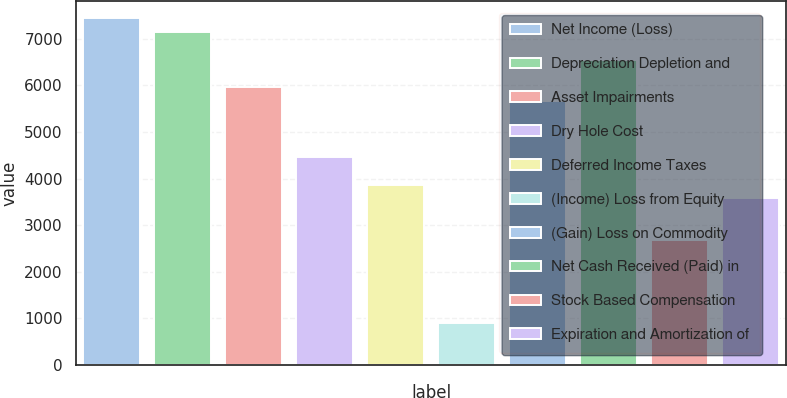Convert chart. <chart><loc_0><loc_0><loc_500><loc_500><bar_chart><fcel>Net Income (Loss)<fcel>Depreciation Depletion and<fcel>Asset Impairments<fcel>Dry Hole Cost<fcel>Deferred Income Taxes<fcel>(Income) Loss from Equity<fcel>(Gain) Loss on Commodity<fcel>Net Cash Received (Paid) in<fcel>Stock Based Compensation<fcel>Expiration and Amortization of<nl><fcel>7446<fcel>7148.2<fcel>5957<fcel>4468<fcel>3872.4<fcel>894.4<fcel>5659.2<fcel>6552.6<fcel>2681.2<fcel>3574.6<nl></chart> 